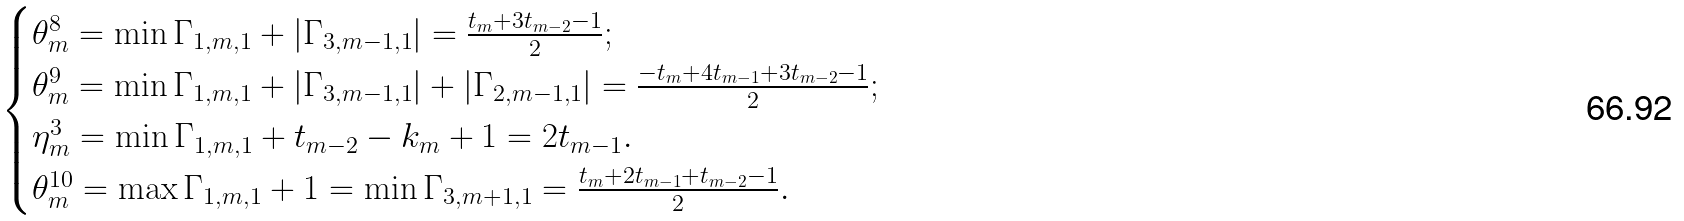Convert formula to latex. <formula><loc_0><loc_0><loc_500><loc_500>\begin{cases} \theta _ { m } ^ { 8 } = \min \Gamma _ { 1 , m , 1 } + | \Gamma _ { 3 , m - 1 , 1 } | = \frac { t _ { m } + 3 t _ { m - 2 } - 1 } { 2 } ; \\ \theta _ { m } ^ { 9 } = \min \Gamma _ { 1 , m , 1 } + | \Gamma _ { 3 , m - 1 , 1 } | + | \Gamma _ { 2 , m - 1 , 1 } | = \frac { - t _ { m } + 4 t _ { m - 1 } + 3 t _ { m - 2 } - 1 } { 2 } ; \\ \eta _ { m } ^ { 3 } = \min \Gamma _ { 1 , m , 1 } + t _ { m - 2 } - k _ { m } + 1 = 2 t _ { m - 1 } . \\ \theta _ { m } ^ { 1 0 } = \max \Gamma _ { 1 , m , 1 } + 1 = \min \Gamma _ { 3 , m + 1 , 1 } = \frac { t _ { m } + 2 t _ { m - 1 } + t _ { m - 2 } - 1 } { 2 } . \end{cases}</formula> 